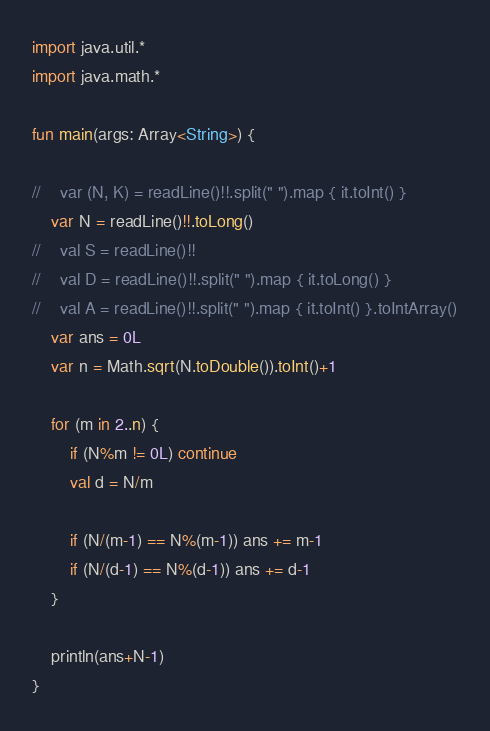Convert code to text. <code><loc_0><loc_0><loc_500><loc_500><_Kotlin_>import java.util.*
import java.math.*

fun main(args: Array<String>) {

//    var (N, K) = readLine()!!.split(" ").map { it.toInt() }
    var N = readLine()!!.toLong()
//    val S = readLine()!!
//    val D = readLine()!!.split(" ").map { it.toLong() }
//    val A = readLine()!!.split(" ").map { it.toInt() }.toIntArray()
    var ans = 0L
    var n = Math.sqrt(N.toDouble()).toInt()+1

    for (m in 2..n) {
        if (N%m != 0L) continue
        val d = N/m

        if (N/(m-1) == N%(m-1)) ans += m-1
        if (N/(d-1) == N%(d-1)) ans += d-1
    }

    println(ans+N-1)
}
</code> 